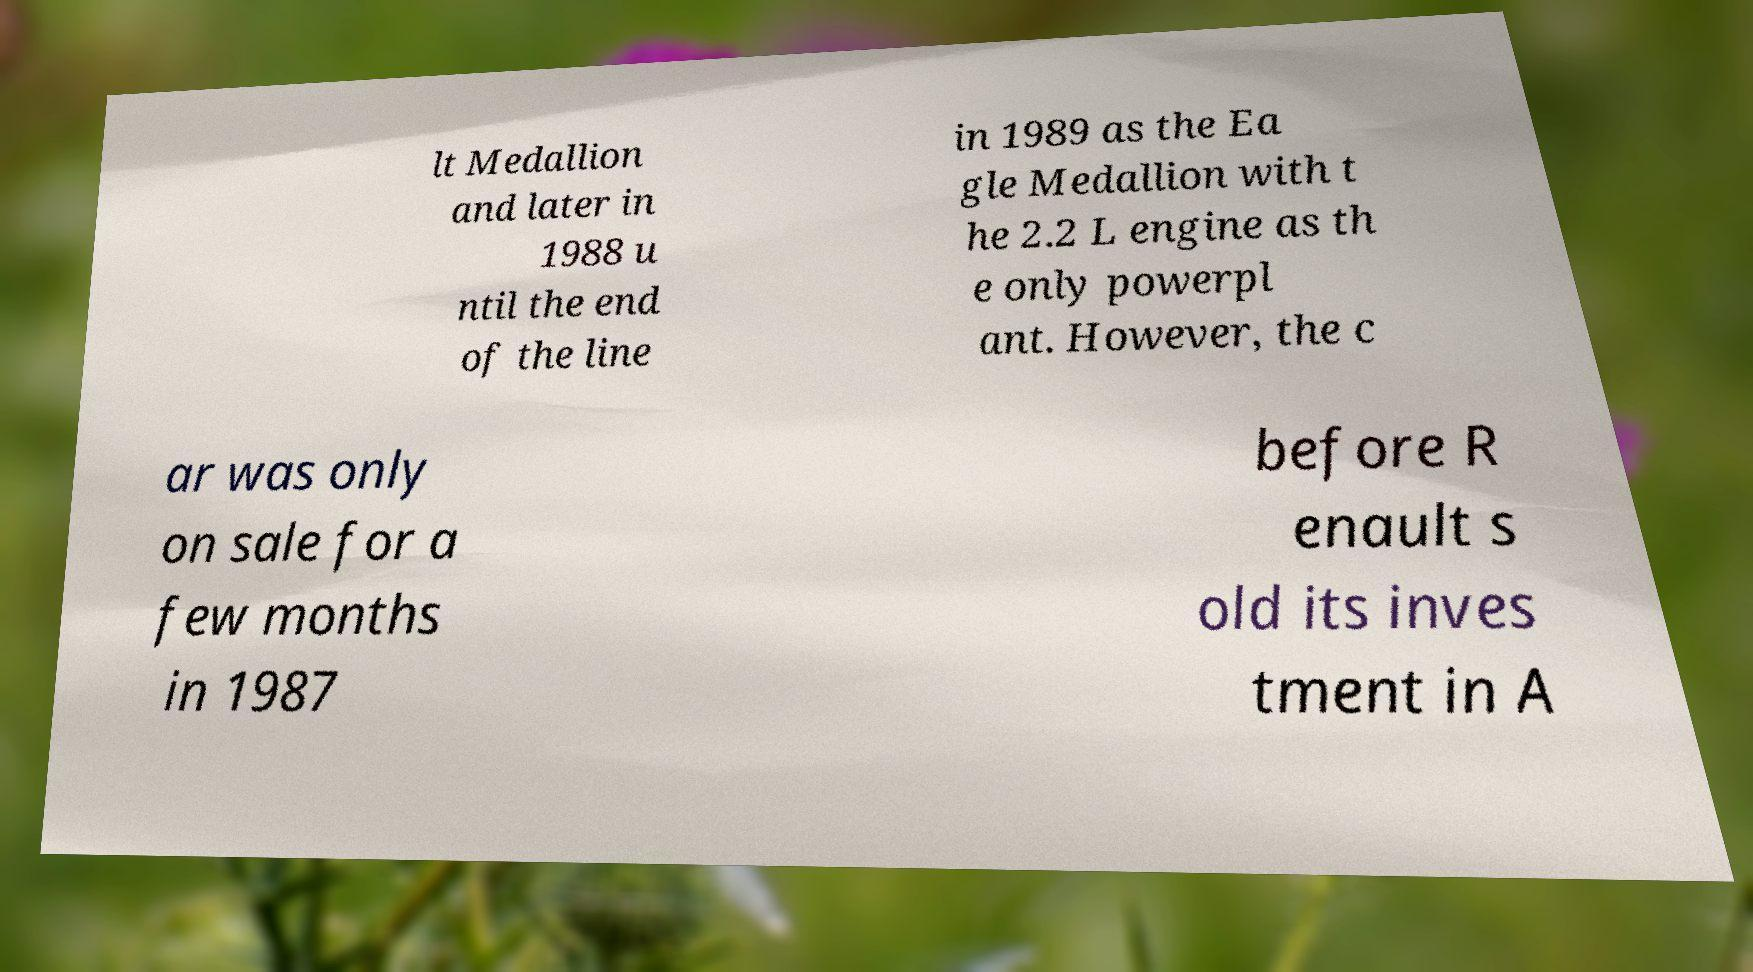Could you extract and type out the text from this image? lt Medallion and later in 1988 u ntil the end of the line in 1989 as the Ea gle Medallion with t he 2.2 L engine as th e only powerpl ant. However, the c ar was only on sale for a few months in 1987 before R enault s old its inves tment in A 